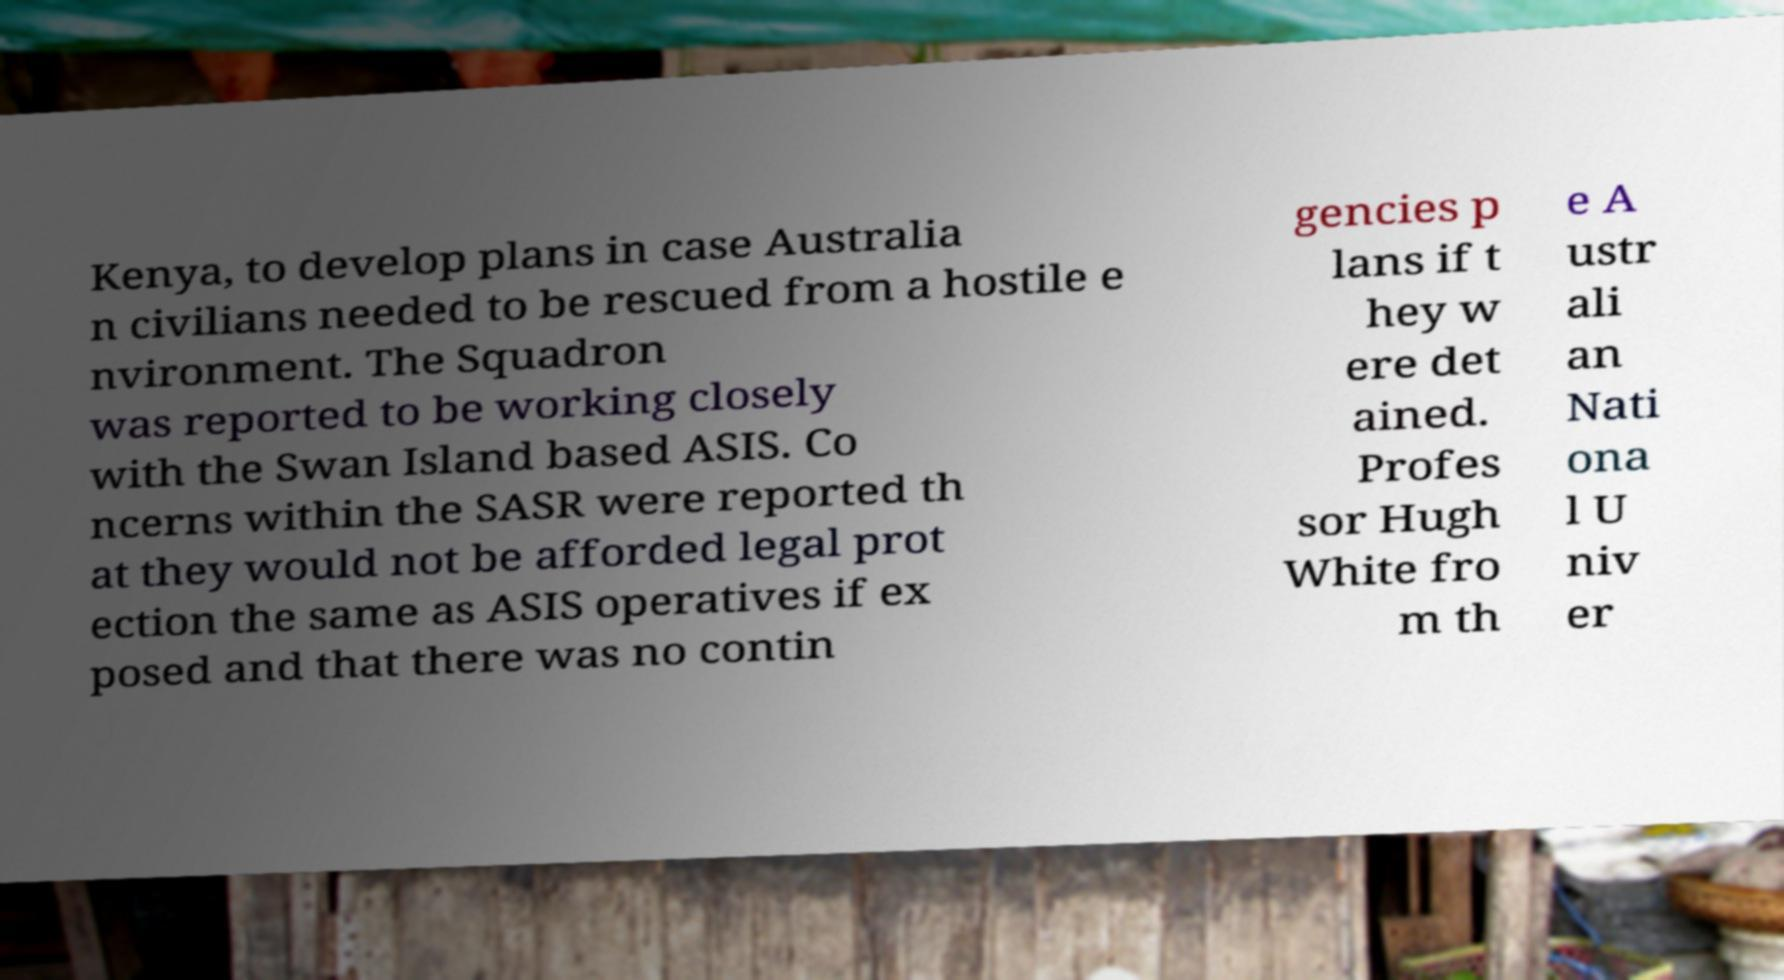For documentation purposes, I need the text within this image transcribed. Could you provide that? Kenya, to develop plans in case Australia n civilians needed to be rescued from a hostile e nvironment. The Squadron was reported to be working closely with the Swan Island based ASIS. Co ncerns within the SASR were reported th at they would not be afforded legal prot ection the same as ASIS operatives if ex posed and that there was no contin gencies p lans if t hey w ere det ained. Profes sor Hugh White fro m th e A ustr ali an Nati ona l U niv er 